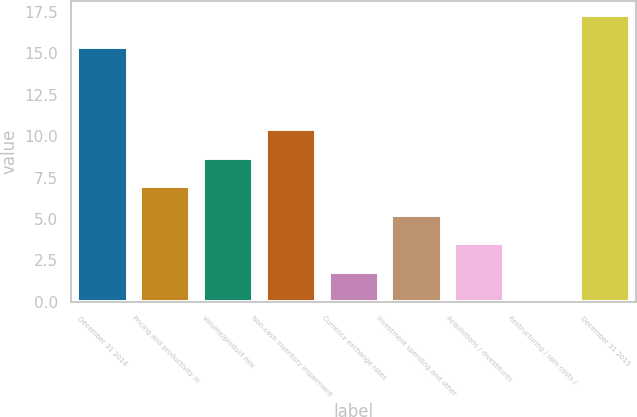Convert chart. <chart><loc_0><loc_0><loc_500><loc_500><bar_chart><fcel>December 31 2014<fcel>Pricing and productivity in<fcel>Volume/product mix<fcel>Non-cash inventory impairment<fcel>Currency exchange rates<fcel>Investment spending and other<fcel>Acquisitions / divestitures<fcel>Restructuring / spin costs /<fcel>December 31 2015<nl><fcel>15.4<fcel>6.98<fcel>8.7<fcel>10.42<fcel>1.82<fcel>5.26<fcel>3.54<fcel>0.1<fcel>17.3<nl></chart> 